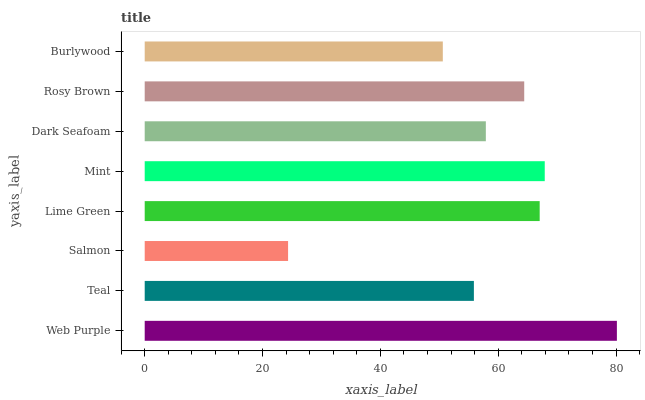Is Salmon the minimum?
Answer yes or no. Yes. Is Web Purple the maximum?
Answer yes or no. Yes. Is Teal the minimum?
Answer yes or no. No. Is Teal the maximum?
Answer yes or no. No. Is Web Purple greater than Teal?
Answer yes or no. Yes. Is Teal less than Web Purple?
Answer yes or no. Yes. Is Teal greater than Web Purple?
Answer yes or no. No. Is Web Purple less than Teal?
Answer yes or no. No. Is Rosy Brown the high median?
Answer yes or no. Yes. Is Dark Seafoam the low median?
Answer yes or no. Yes. Is Salmon the high median?
Answer yes or no. No. Is Lime Green the low median?
Answer yes or no. No. 